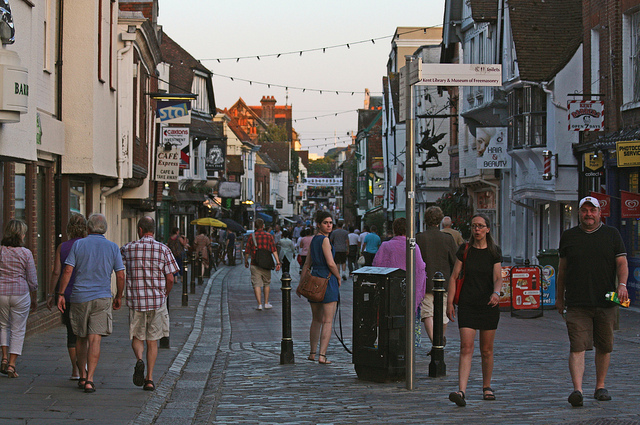Can you identify any specific types of shops or establishments in the image? There is a variety of establishments visible. For instance, directly ahead, a sign can be seen for what appears to be a café, as well as a sign for 'Books', indicating a bookstore. There are also other signs that are less legible but suggest a diversity of shopping options for pedestrians. 